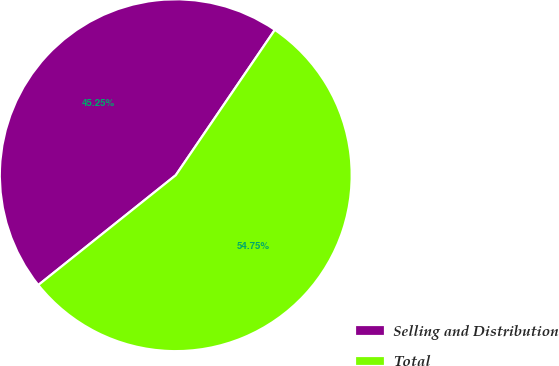Convert chart. <chart><loc_0><loc_0><loc_500><loc_500><pie_chart><fcel>Selling and Distribution<fcel>Total<nl><fcel>45.25%<fcel>54.75%<nl></chart> 